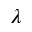<formula> <loc_0><loc_0><loc_500><loc_500>\lambda</formula> 